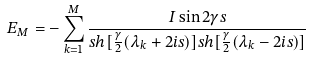<formula> <loc_0><loc_0><loc_500><loc_500>E _ { M } = - \sum _ { k = 1 } ^ { M } \frac { I \sin 2 \gamma s } { s h [ \frac { \gamma } { 2 } ( \lambda _ { k } + 2 i s ) ] s h [ \frac { \gamma } { 2 } ( \lambda _ { k } - 2 i s ) ] }</formula> 